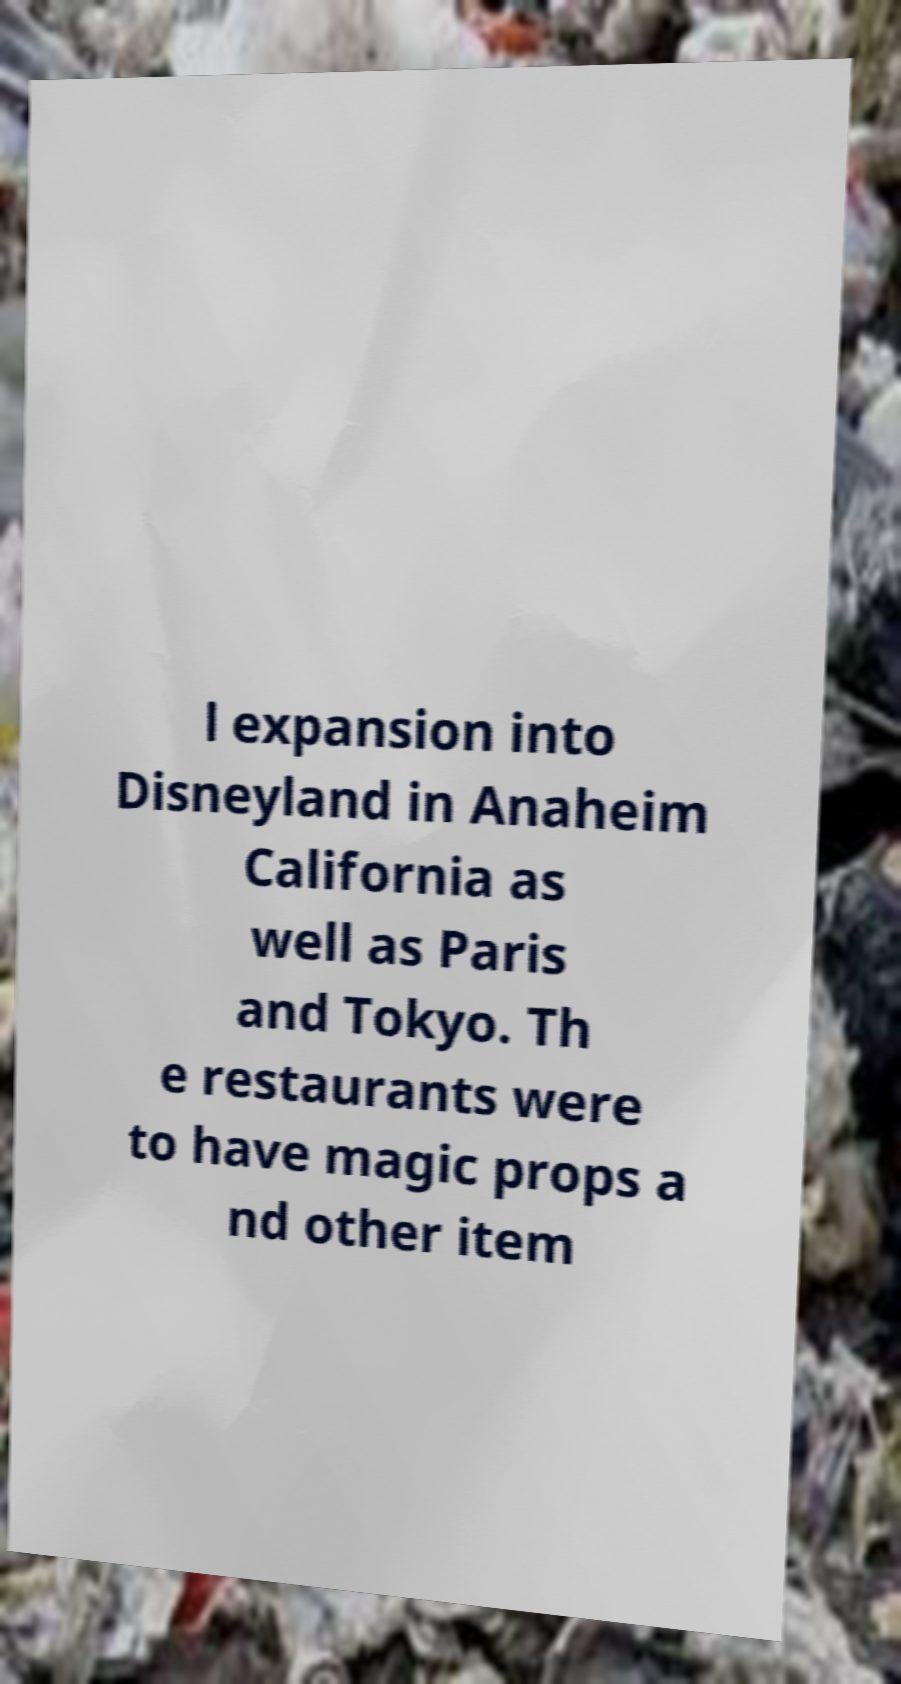Can you read and provide the text displayed in the image?This photo seems to have some interesting text. Can you extract and type it out for me? l expansion into Disneyland in Anaheim California as well as Paris and Tokyo. Th e restaurants were to have magic props a nd other item 